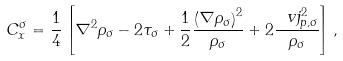Convert formula to latex. <formula><loc_0><loc_0><loc_500><loc_500>C ^ { \sigma } _ { x } = \frac { 1 } { 4 } \left [ \nabla ^ { 2 } \rho _ { \sigma } - 2 \tau _ { \sigma } + \frac { 1 } { 2 } \frac { \left ( \nabla \rho _ { \sigma } \right ) ^ { 2 } } { \rho _ { \sigma } } + 2 \frac { \ v j ^ { 2 } _ { p , \sigma } } { \rho _ { \sigma } } \right ] ,</formula> 